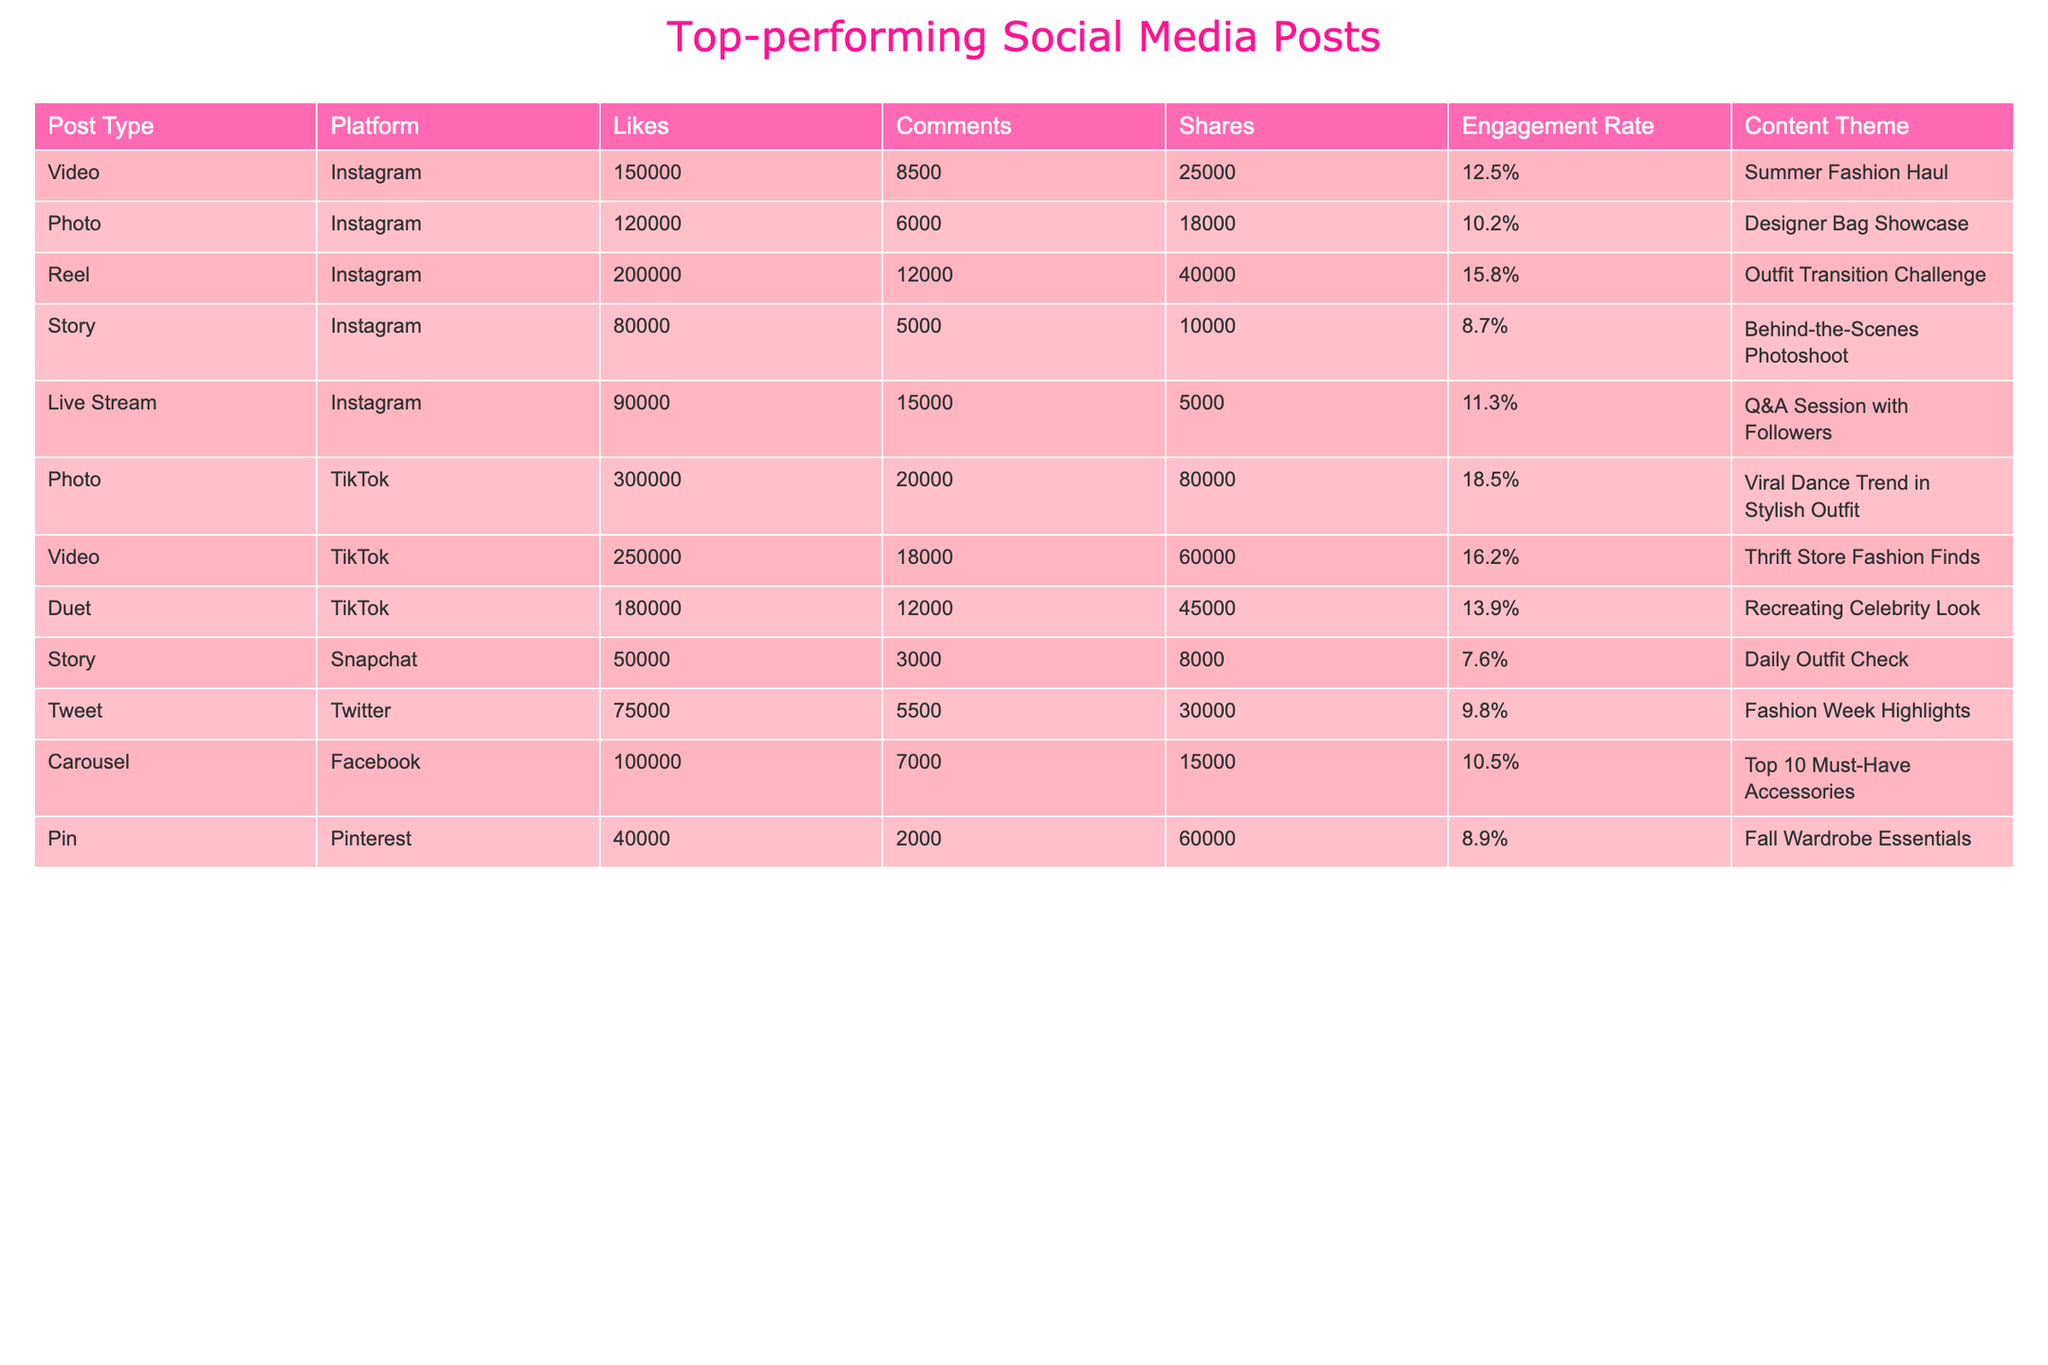What is the post type with the highest engagement rate? Looking at the engagement rate column, the Reel post on Instagram has the highest engagement rate of 15.8%.
Answer: Reel What platform had the post with the most likes? The TikTok platform had the post with the most likes, which is a photo with 300,000 likes.
Answer: TikTok How many total comments did the Instagram posts receive? Adding the comments from Instagram: 8500 + 6000 + 12000 + 5000 + 15000 = 40000 total comments.
Answer: 40000 Was the Designer Bag Showcase photo the most shared post? No, the Designer Bag Showcase photo had 18,000 shares, while the Viral Dance Trend post on TikTok had 80,000 shares, making it the most shared post.
Answer: No What is the difference in likes between the best and worst performing posts? The best performing post is the TikTok post with 300,000 likes, and the worst is the Snapchat post with 50,000 likes. The difference is 300,000 - 50,000 = 250,000 likes.
Answer: 250000 Which post had the highest number of shares? The TikTok post titled "Viral Dance Trend in Stylish Outfit" had the highest number of shares, totaling 80,000.
Answer: Viral Dance Trend in Stylish Outfit What is the average engagement rate of all posts across platforms? To find the average, add the engagement rates (12.5 + 10.2 + 15.8 + 8.7 + 11.3 + 18.5 + 16.2 + 13.9 + 7.6 + 9.8 + 10.5 + 8.9) = 142.4, then divide by 12 (the number of posts). The average engagement rate is 142.4 / 12 = approximately 11.87%.
Answer: 11.87% Which post type is most associated with higher engagement rates? Examining the engagement rates: Reels and Videos generally have higher rates, notably the Reels with a 15.8% and Videos averaging 12.5%. Thus, Reels seem to be associated with higher engagement rates.
Answer: Reels Did the top-performing TikTok post have more likes than any of the Twitter posts? Yes, the top TikTok post received 300,000 likes, significantly higher than Twitter posts, with the highest at 75,000 likes.
Answer: Yes How many more comments did the top Instagram post receive compared to the bottom Instagram post? The top post (Reel) had 12,000 comments, while the bottom post (Story) had 5,000 comments. The difference is 12,000 - 5,000 = 7,000 comments.
Answer: 7000 